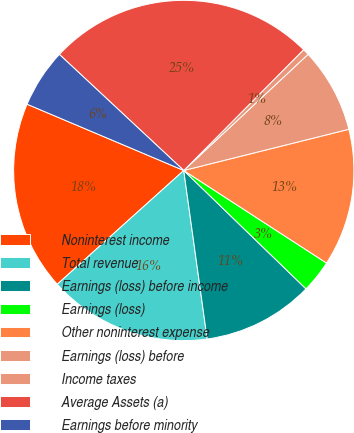Convert chart to OTSL. <chart><loc_0><loc_0><loc_500><loc_500><pie_chart><fcel>Noninterest income<fcel>Total revenue<fcel>Earnings (loss) before income<fcel>Earnings (loss)<fcel>Other noninterest expense<fcel>Earnings (loss) before<fcel>Income taxes<fcel>Average Assets (a)<fcel>Earnings before minority<nl><fcel>18.03%<fcel>15.54%<fcel>10.56%<fcel>3.09%<fcel>13.05%<fcel>8.07%<fcel>0.6%<fcel>25.49%<fcel>5.58%<nl></chart> 